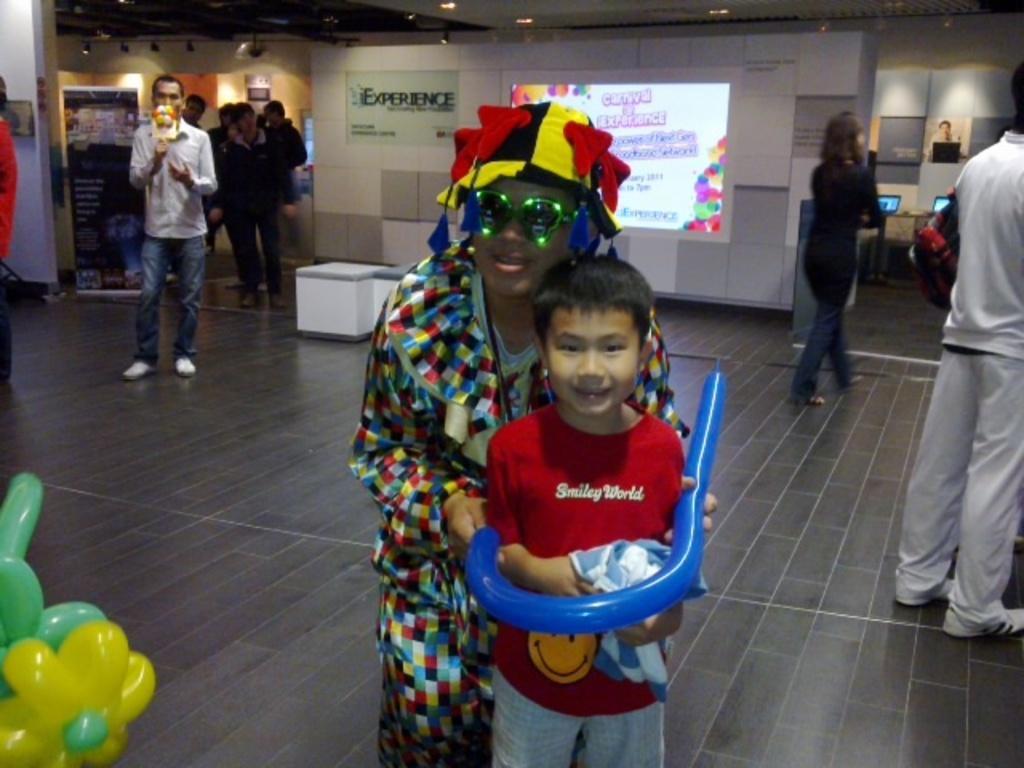Describe this image in one or two sentences. In this image, there are a few people. We can see the ground with some objects. We can see some boards with text and images. We can also see the wall and the roof with some lights. We can also see some objects on the bottom left. 